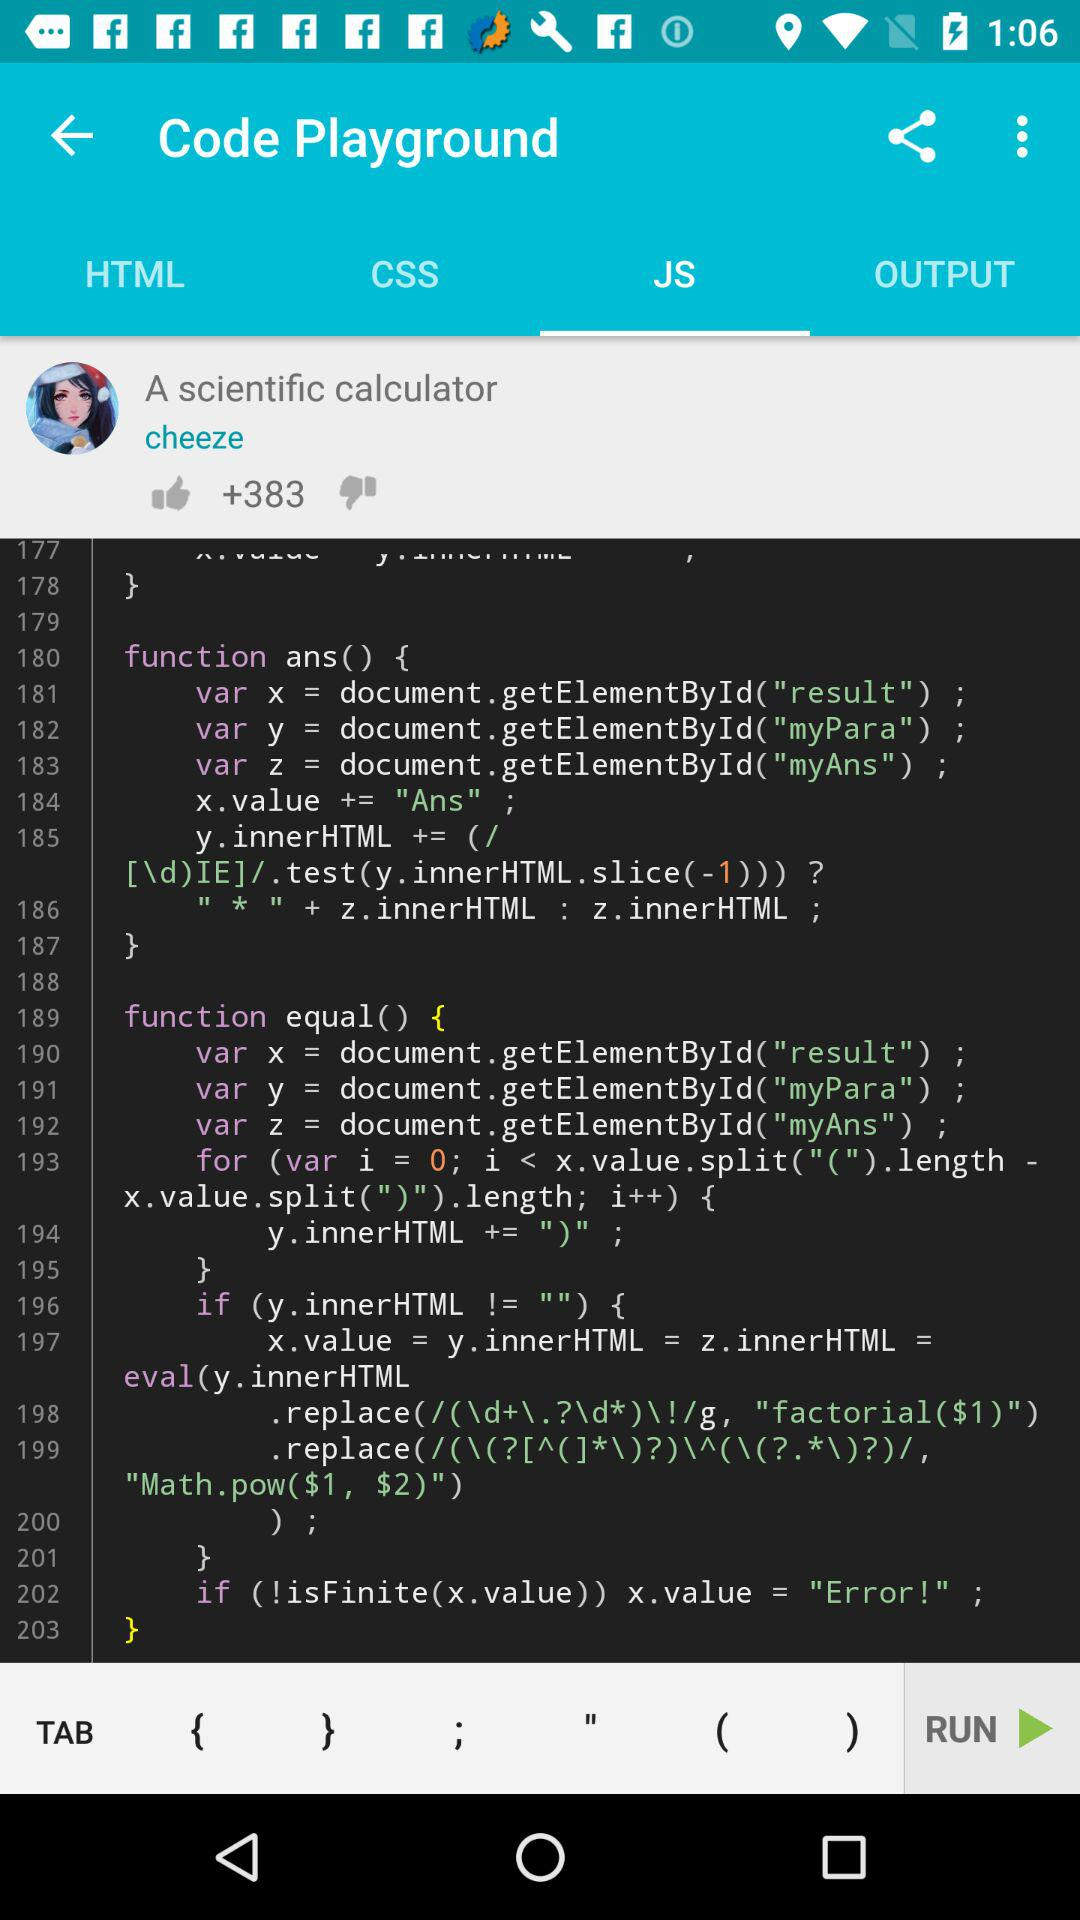Which option is selected in "Code Playground"? The selected option is "JS". 